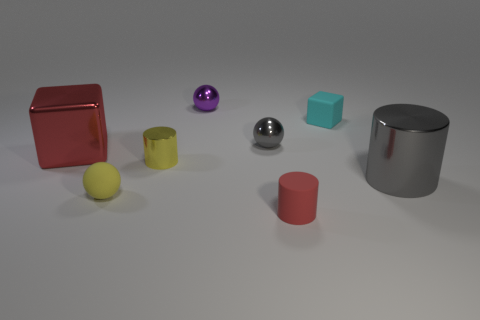There is a object that is both right of the red rubber cylinder and behind the shiny cube; what is its material?
Your answer should be compact. Rubber. What color is the tiny thing behind the tiny rubber object that is behind the cube in front of the small cube?
Offer a very short reply. Purple. The metallic cylinder that is the same size as the yellow sphere is what color?
Keep it short and to the point. Yellow. There is a rubber ball; does it have the same color as the big cube behind the red matte cylinder?
Give a very brief answer. No. What material is the tiny red object that is in front of the large thing that is right of the cyan cube made of?
Offer a terse response. Rubber. How many spheres are behind the small rubber ball and in front of the small rubber block?
Offer a terse response. 1. How many other objects are there of the same size as the matte cylinder?
Provide a short and direct response. 5. Do the big thing that is on the left side of the small gray object and the gray metal object to the left of the small cyan block have the same shape?
Your answer should be very brief. No. There is a large red metallic block; are there any big metal cylinders in front of it?
Your answer should be very brief. Yes. What color is the other small rubber thing that is the same shape as the purple object?
Provide a short and direct response. Yellow. 